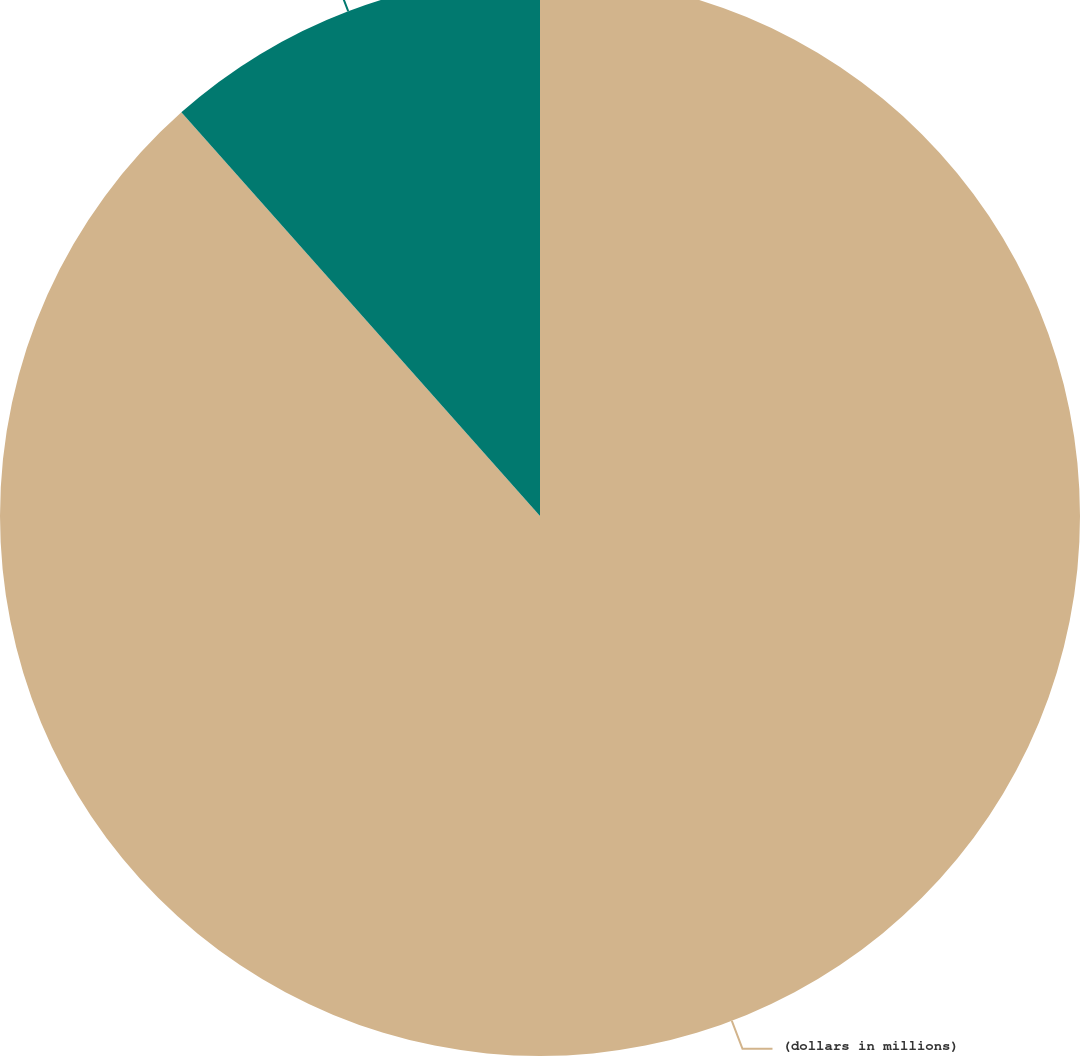Convert chart. <chart><loc_0><loc_0><loc_500><loc_500><pie_chart><fcel>(dollars in millions)<fcel>Gross interest expense<nl><fcel>88.44%<fcel>11.56%<nl></chart> 